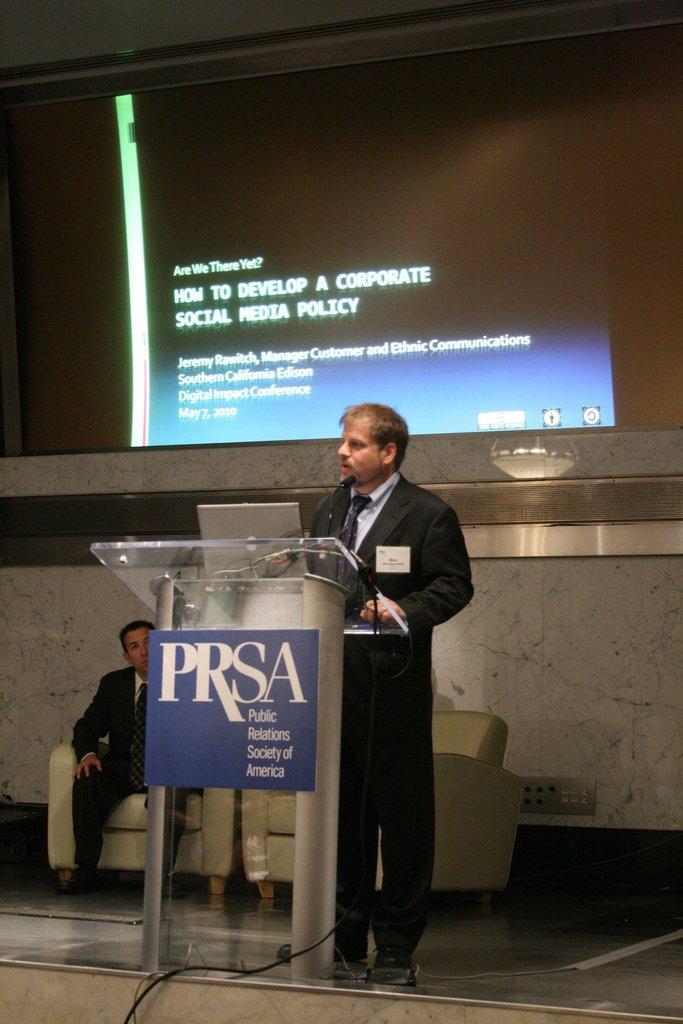Could you give a brief overview of what you see in this image? In this image there is a person standing in front of a podium, for that podium there is a poster, on that poster there is some text, on that podium there is a laptop and a mic, in the background there is a person sitting on a chair and the is a monitor on that there is some text. 